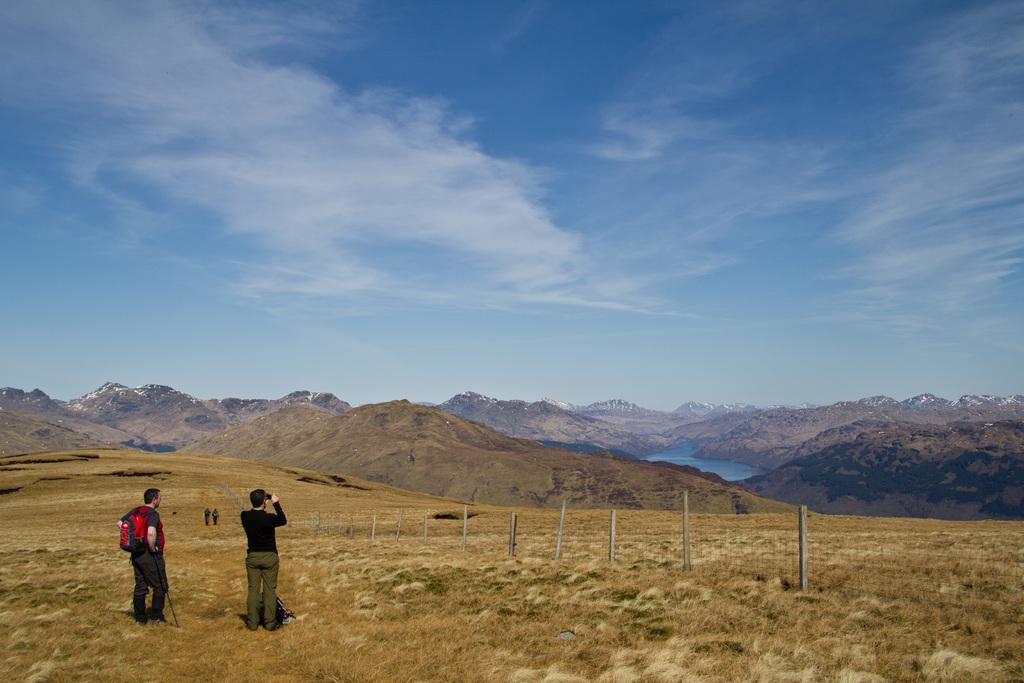What can be seen in the front of the image? There are people and wooden sticks in the front of the image. What is the terrain like in the image? The land is covered with grass. What can be seen in the background of the image? There are mountains, water, and a cloudy sky visible in the background of the image. What type of crime is being committed in the image? There is no crime being committed in the image; it features people and wooden sticks in a grassy area with mountains and water in the background. How many mines are visible in the image? There are no mines present in the image. 